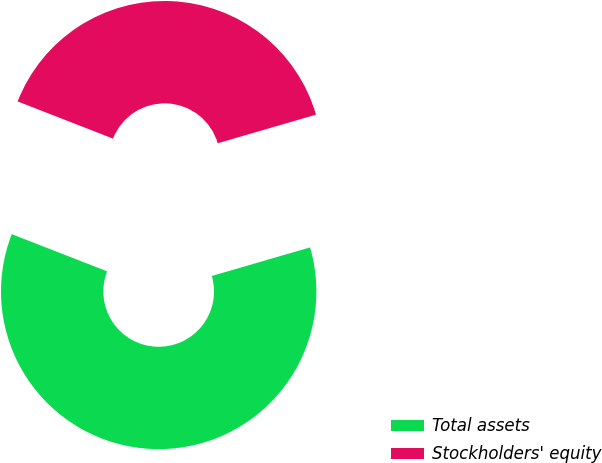Convert chart to OTSL. <chart><loc_0><loc_0><loc_500><loc_500><pie_chart><fcel>Total assets<fcel>Stockholders' equity<nl><fcel>60.42%<fcel>39.58%<nl></chart> 